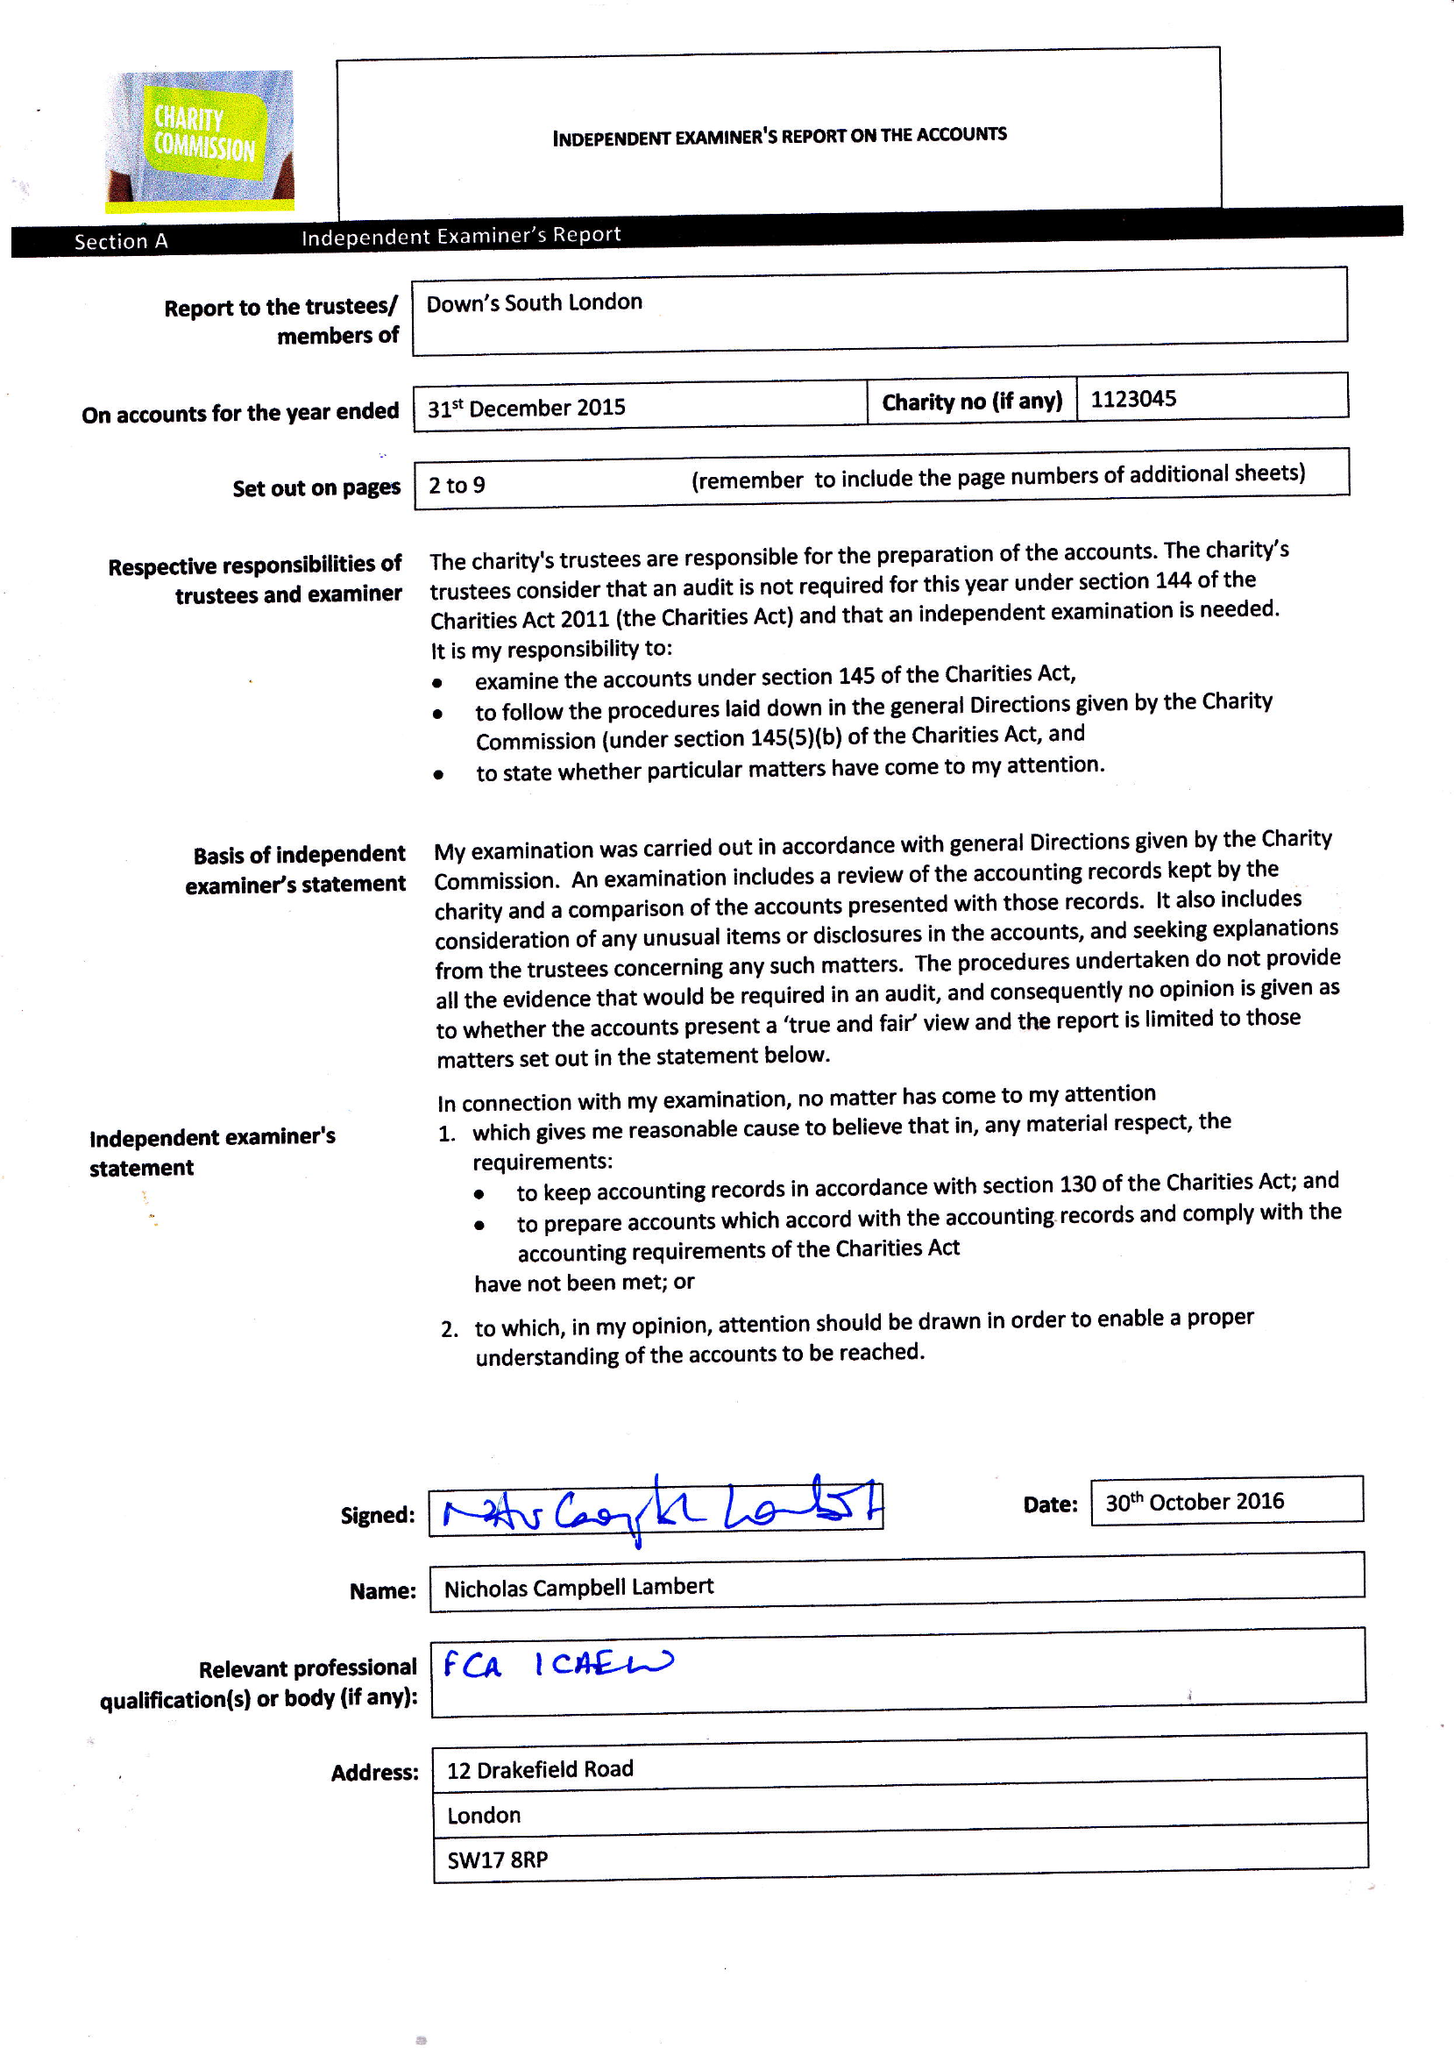What is the value for the charity_name?
Answer the question using a single word or phrase. Down's South London 